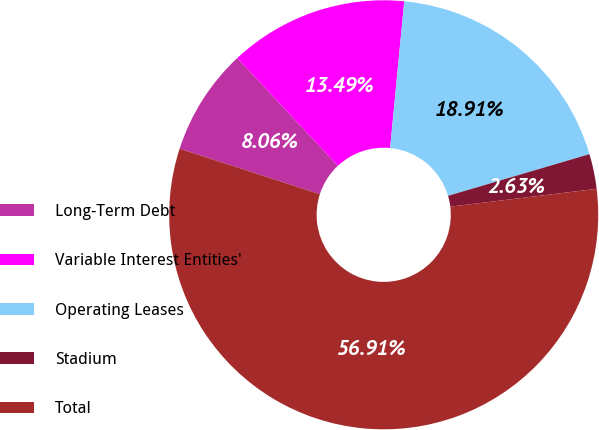<chart> <loc_0><loc_0><loc_500><loc_500><pie_chart><fcel>Long-Term Debt<fcel>Variable Interest Entities'<fcel>Operating Leases<fcel>Stadium<fcel>Total<nl><fcel>8.06%<fcel>13.49%<fcel>18.91%<fcel>2.63%<fcel>56.92%<nl></chart> 